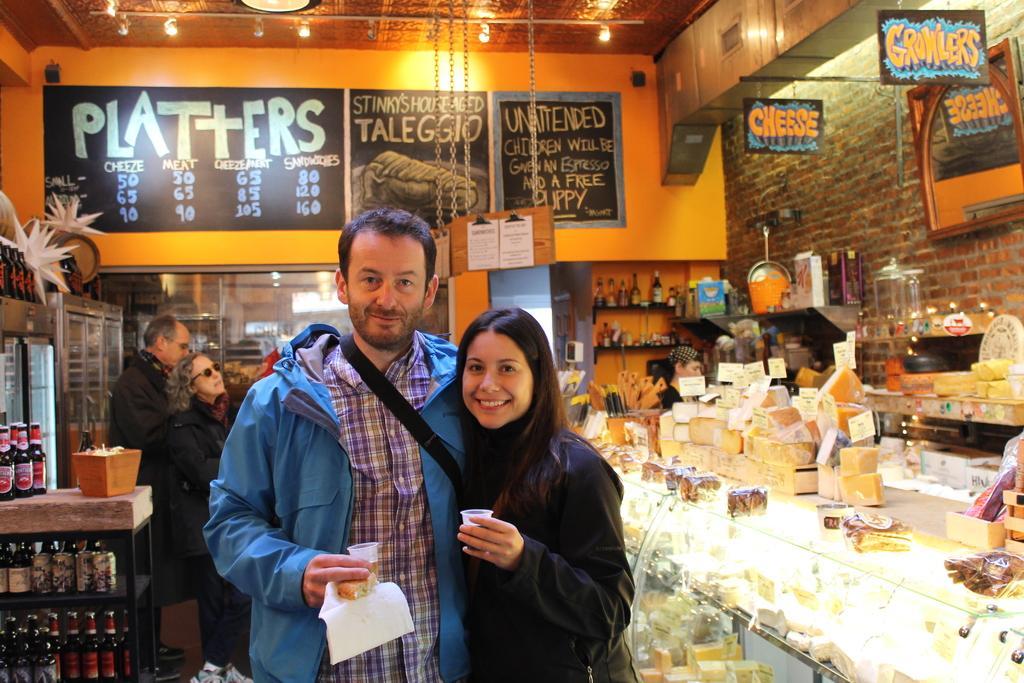How would you summarize this image in a sentence or two? In this image I can see two persons holding cups in their hands are standing. I can see a glass box with few food items in it and few items on it, few racks with glass bottles in them and in the background I can see few other persons standing, a few boards, the ceiling, few lights to the ceiling, the wall and few other objects. 